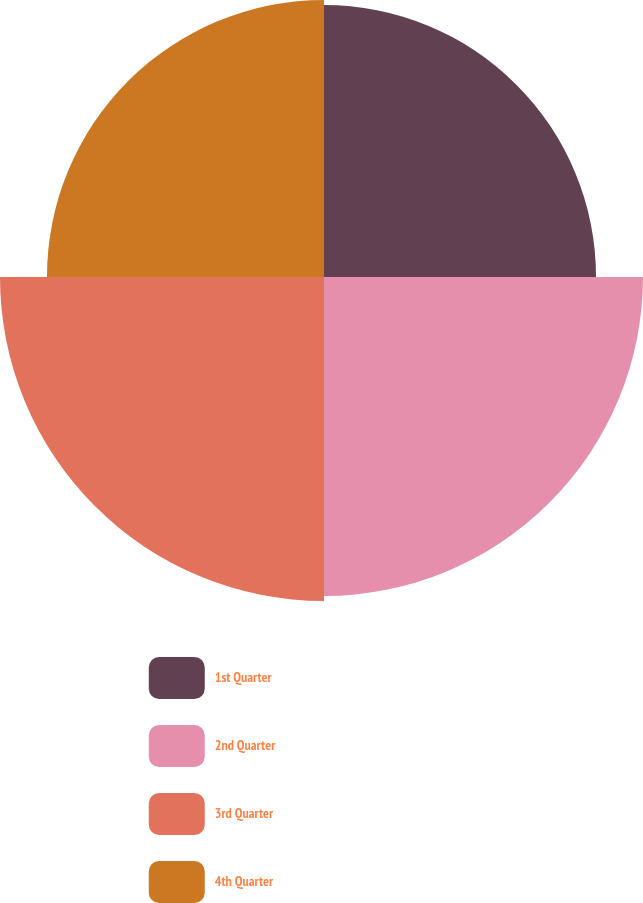<chart> <loc_0><loc_0><loc_500><loc_500><pie_chart><fcel>1st Quarter<fcel>2nd Quarter<fcel>3rd Quarter<fcel>4th Quarter<nl><fcel>22.82%<fcel>26.76%<fcel>27.18%<fcel>23.24%<nl></chart> 